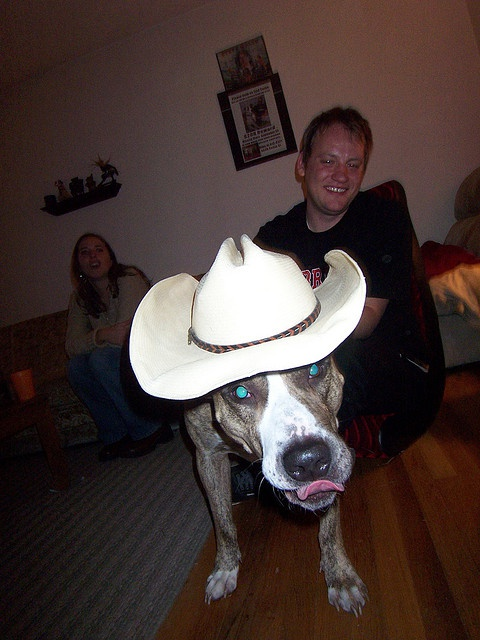Describe the objects in this image and their specific colors. I can see people in black, maroon, and brown tones, dog in black, gray, white, and darkgray tones, people in black and white tones, couch in black tones, and cup in black and maroon tones in this image. 